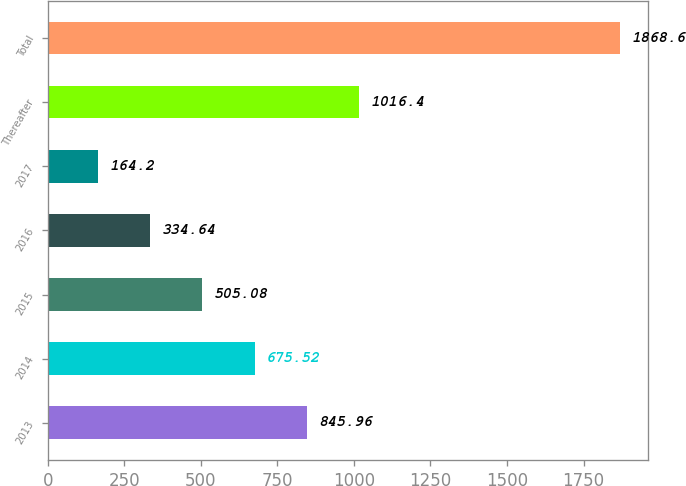<chart> <loc_0><loc_0><loc_500><loc_500><bar_chart><fcel>2013<fcel>2014<fcel>2015<fcel>2016<fcel>2017<fcel>Thereafter<fcel>Total<nl><fcel>845.96<fcel>675.52<fcel>505.08<fcel>334.64<fcel>164.2<fcel>1016.4<fcel>1868.6<nl></chart> 